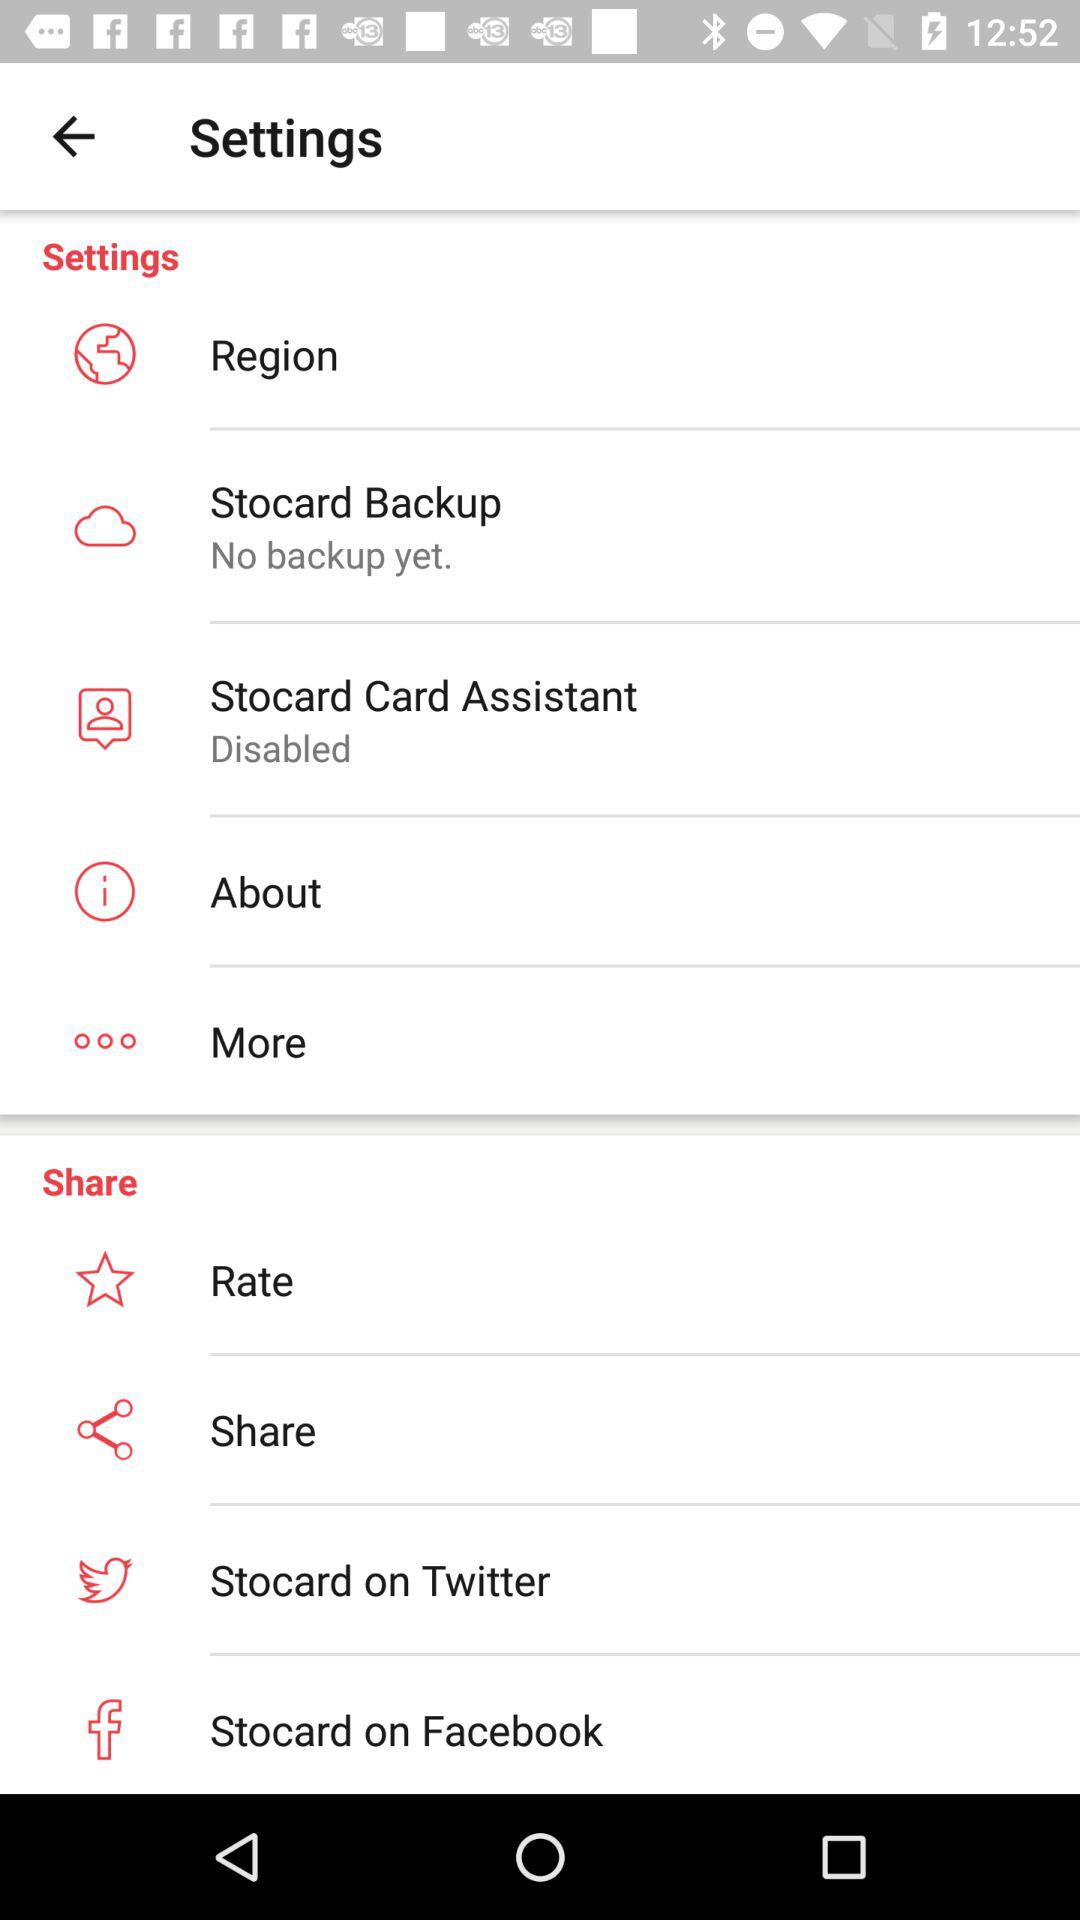What is the name of the application? The name of the application is "Stocard". 